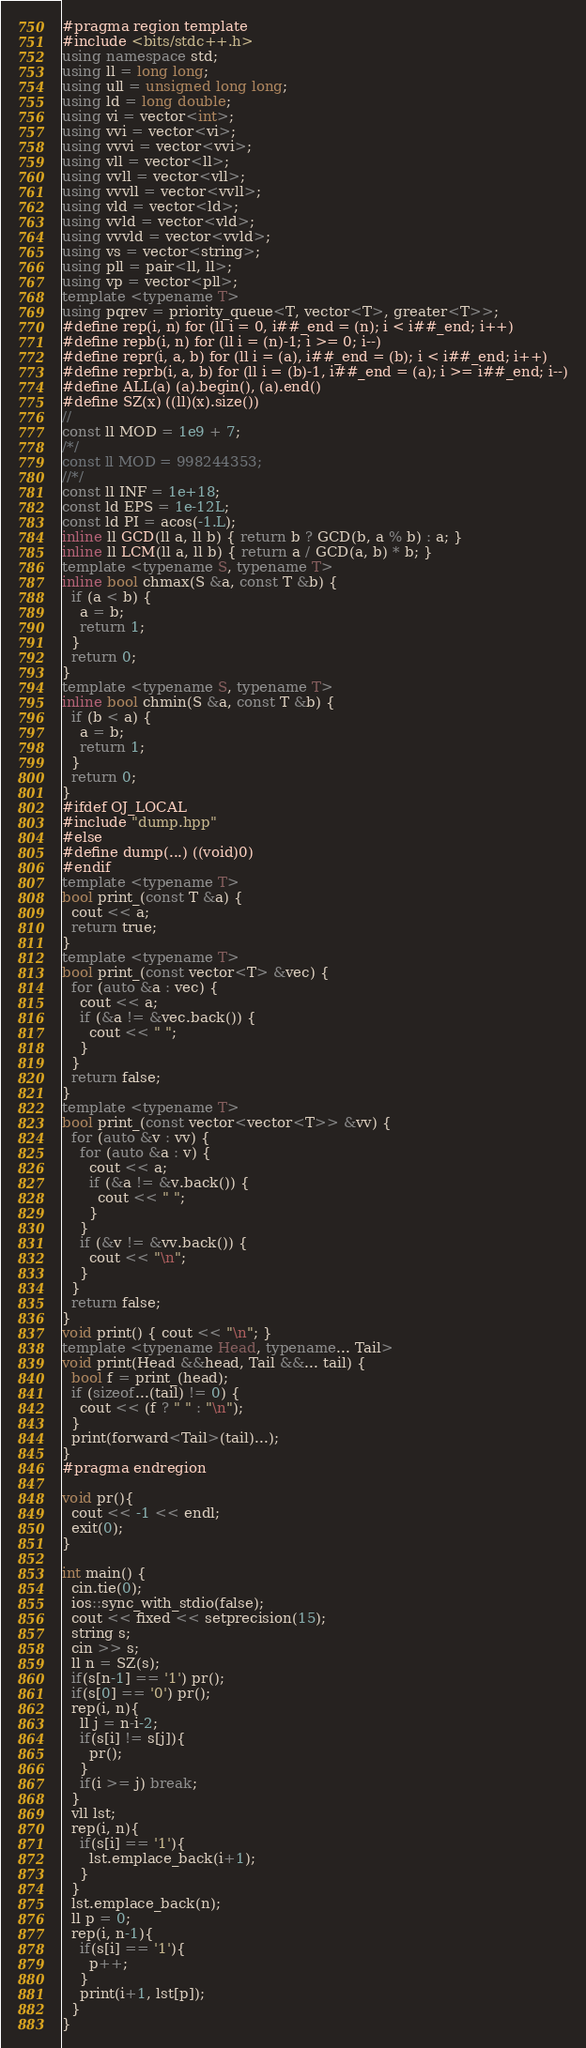<code> <loc_0><loc_0><loc_500><loc_500><_C++_>#pragma region template
#include <bits/stdc++.h>
using namespace std;
using ll = long long;
using ull = unsigned long long;
using ld = long double;
using vi = vector<int>;
using vvi = vector<vi>;
using vvvi = vector<vvi>;
using vll = vector<ll>;
using vvll = vector<vll>;
using vvvll = vector<vvll>;
using vld = vector<ld>;
using vvld = vector<vld>;
using vvvld = vector<vvld>;
using vs = vector<string>;
using pll = pair<ll, ll>;
using vp = vector<pll>;
template <typename T>
using pqrev = priority_queue<T, vector<T>, greater<T>>;
#define rep(i, n) for (ll i = 0, i##_end = (n); i < i##_end; i++)
#define repb(i, n) for (ll i = (n)-1; i >= 0; i--)
#define repr(i, a, b) for (ll i = (a), i##_end = (b); i < i##_end; i++)
#define reprb(i, a, b) for (ll i = (b)-1, i##_end = (a); i >= i##_end; i--)
#define ALL(a) (a).begin(), (a).end()
#define SZ(x) ((ll)(x).size())
//
const ll MOD = 1e9 + 7;
/*/
const ll MOD = 998244353;
//*/
const ll INF = 1e+18;
const ld EPS = 1e-12L;
const ld PI = acos(-1.L);
inline ll GCD(ll a, ll b) { return b ? GCD(b, a % b) : a; }
inline ll LCM(ll a, ll b) { return a / GCD(a, b) * b; }
template <typename S, typename T>
inline bool chmax(S &a, const T &b) {
  if (a < b) {
    a = b;
    return 1;
  }
  return 0;
}
template <typename S, typename T>
inline bool chmin(S &a, const T &b) {
  if (b < a) {
    a = b;
    return 1;
  }
  return 0;
}
#ifdef OJ_LOCAL
#include "dump.hpp"
#else
#define dump(...) ((void)0)
#endif
template <typename T>
bool print_(const T &a) {
  cout << a;
  return true;
}
template <typename T>
bool print_(const vector<T> &vec) {
  for (auto &a : vec) {
    cout << a;
    if (&a != &vec.back()) {
      cout << " ";
    }
  }
  return false;
}
template <typename T>
bool print_(const vector<vector<T>> &vv) {
  for (auto &v : vv) {
    for (auto &a : v) {
      cout << a;
      if (&a != &v.back()) {
        cout << " ";
      }
    }
    if (&v != &vv.back()) {
      cout << "\n";
    }
  }
  return false;
}
void print() { cout << "\n"; }
template <typename Head, typename... Tail>
void print(Head &&head, Tail &&... tail) {
  bool f = print_(head);
  if (sizeof...(tail) != 0) {
    cout << (f ? " " : "\n");
  }
  print(forward<Tail>(tail)...);
}
#pragma endregion

void pr(){
  cout << -1 << endl;
  exit(0);
}

int main() {
  cin.tie(0);
  ios::sync_with_stdio(false);
  cout << fixed << setprecision(15);
  string s;
  cin >> s;
  ll n = SZ(s);
  if(s[n-1] == '1') pr();
  if(s[0] == '0') pr();
  rep(i, n){
    ll j = n-i-2;
    if(s[i] != s[j]){
      pr();
    }
    if(i >= j) break;
  }
  vll lst;
  rep(i, n){
    if(s[i] == '1'){
      lst.emplace_back(i+1);
    }
  }
  lst.emplace_back(n);
  ll p = 0;
  rep(i, n-1){
    if(s[i] == '1'){
      p++;
    }
    print(i+1, lst[p]);
  }
}
</code> 